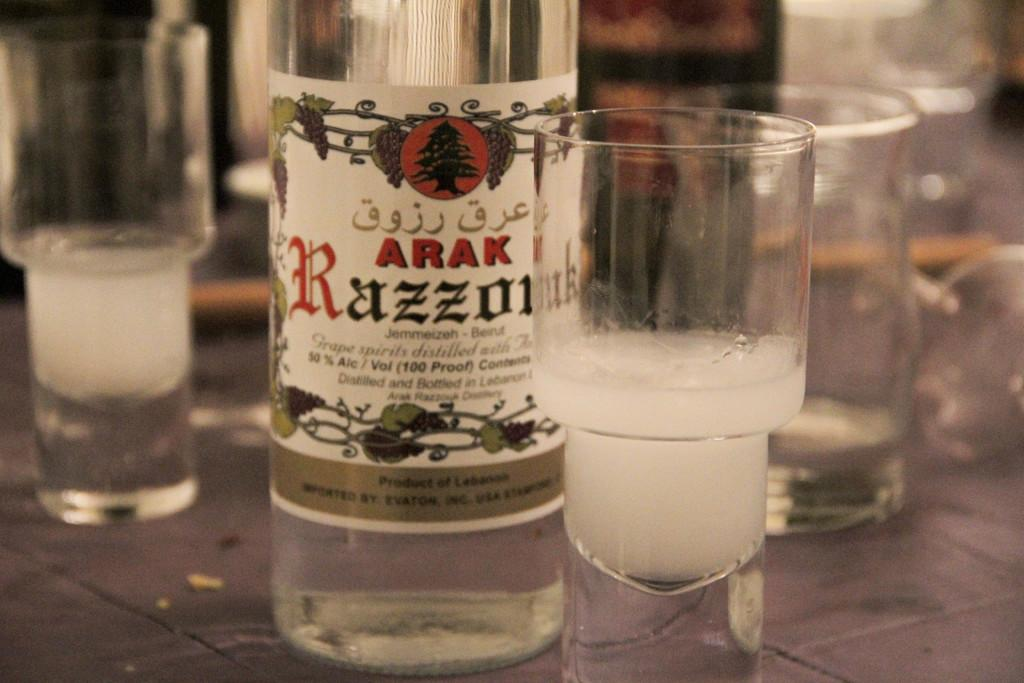<image>
Present a compact description of the photo's key features. A bottle of liquor that is called ARAK Razzolmie and states it is 100 proof sitting on a table with glasses. 